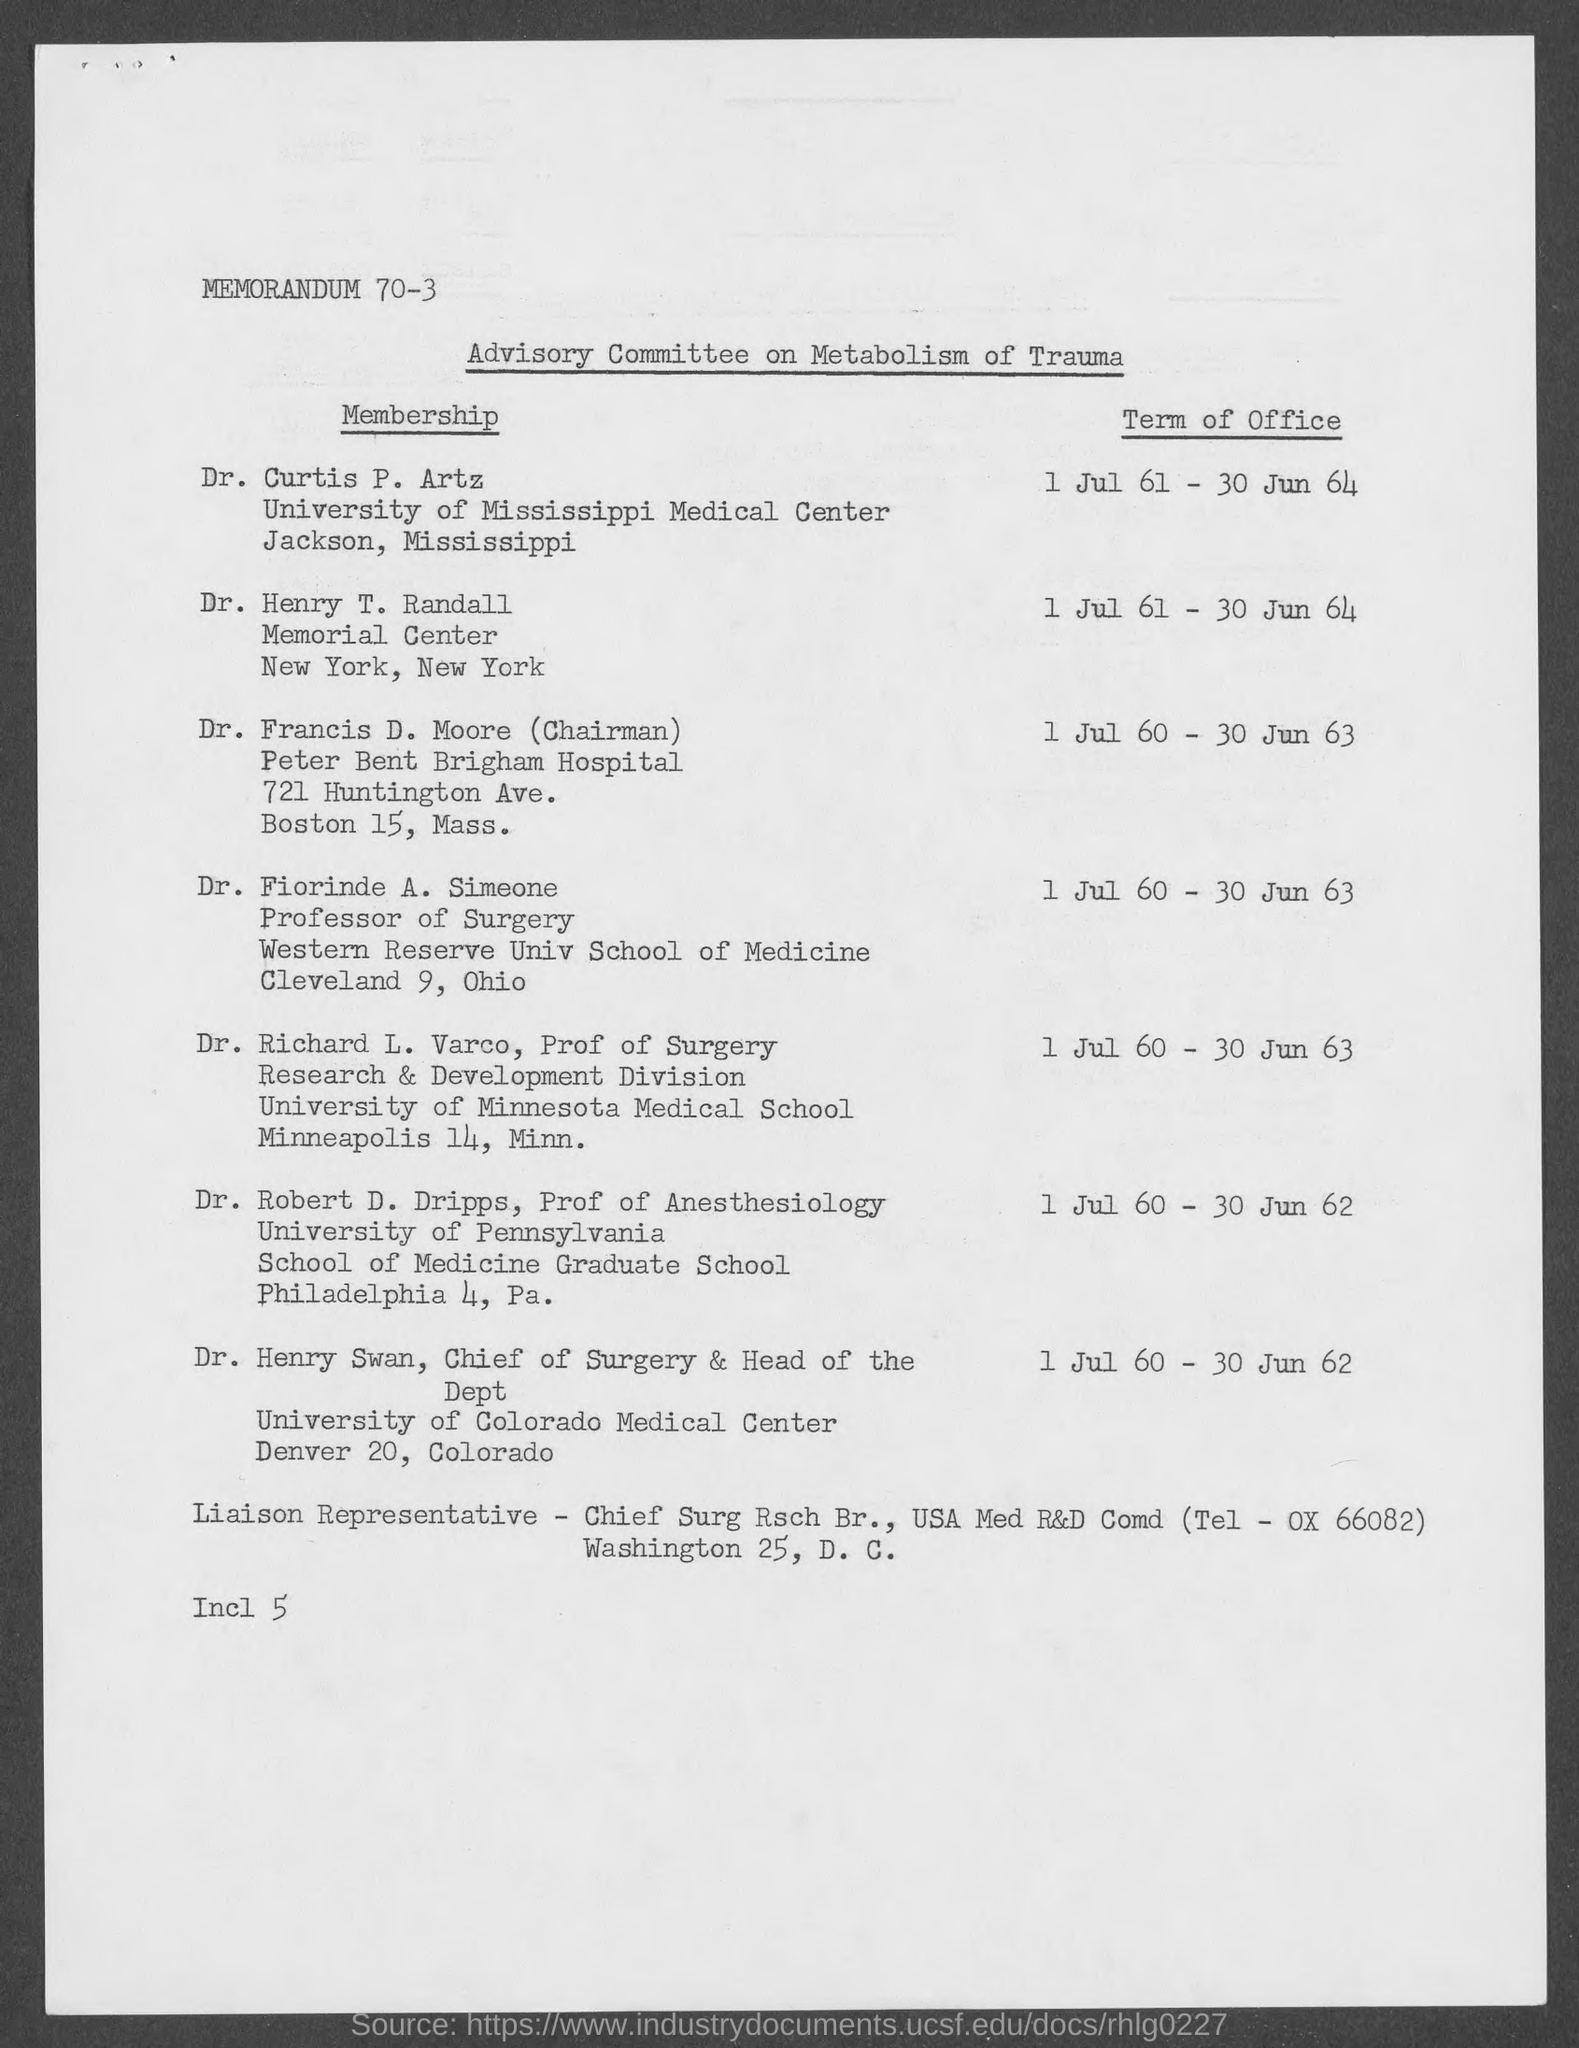To which university does dr. curtis belong ?
Make the answer very short. University of Mississippi Medical Center. What is the position of dr. fiorinde a. simeone?
Provide a short and direct response. Professor of Surgery. What is the memorandum no.?
Give a very brief answer. 70-3. To which university does dr. robert d. dripps belong ?
Give a very brief answer. University of Pennsylvania. To which university does dr. henry swan belong ?
Offer a very short reply. University of Colorado Medical Center. 